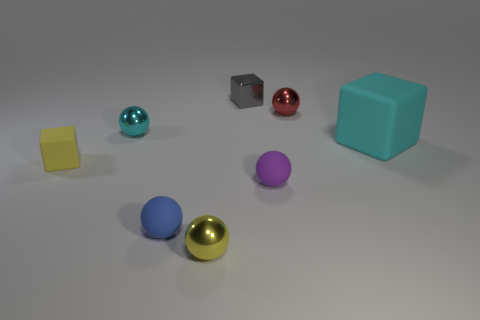There is a small shiny object that is right of the tiny gray thing; is it the same shape as the rubber thing that is behind the yellow cube?
Your answer should be compact. No. There is a cube to the right of the tiny cube behind the rubber thing behind the tiny yellow matte thing; what size is it?
Keep it short and to the point. Large. There is a matte cube to the right of the yellow block; how big is it?
Ensure brevity in your answer.  Large. What is the tiny cube that is on the right side of the small blue rubber ball made of?
Give a very brief answer. Metal. How many brown things are either small matte cubes or balls?
Your response must be concise. 0. Is the material of the red sphere the same as the cyan object left of the cyan cube?
Your response must be concise. Yes. Is the number of blue matte balls that are right of the purple rubber object the same as the number of small spheres that are left of the red ball?
Offer a terse response. No. Does the yellow rubber block have the same size as the rubber cube that is to the right of the blue ball?
Make the answer very short. No. Is the number of gray metallic things that are on the left side of the small blue rubber ball greater than the number of tiny red spheres?
Provide a short and direct response. No. What number of purple balls have the same size as the red metallic object?
Your answer should be compact. 1. 